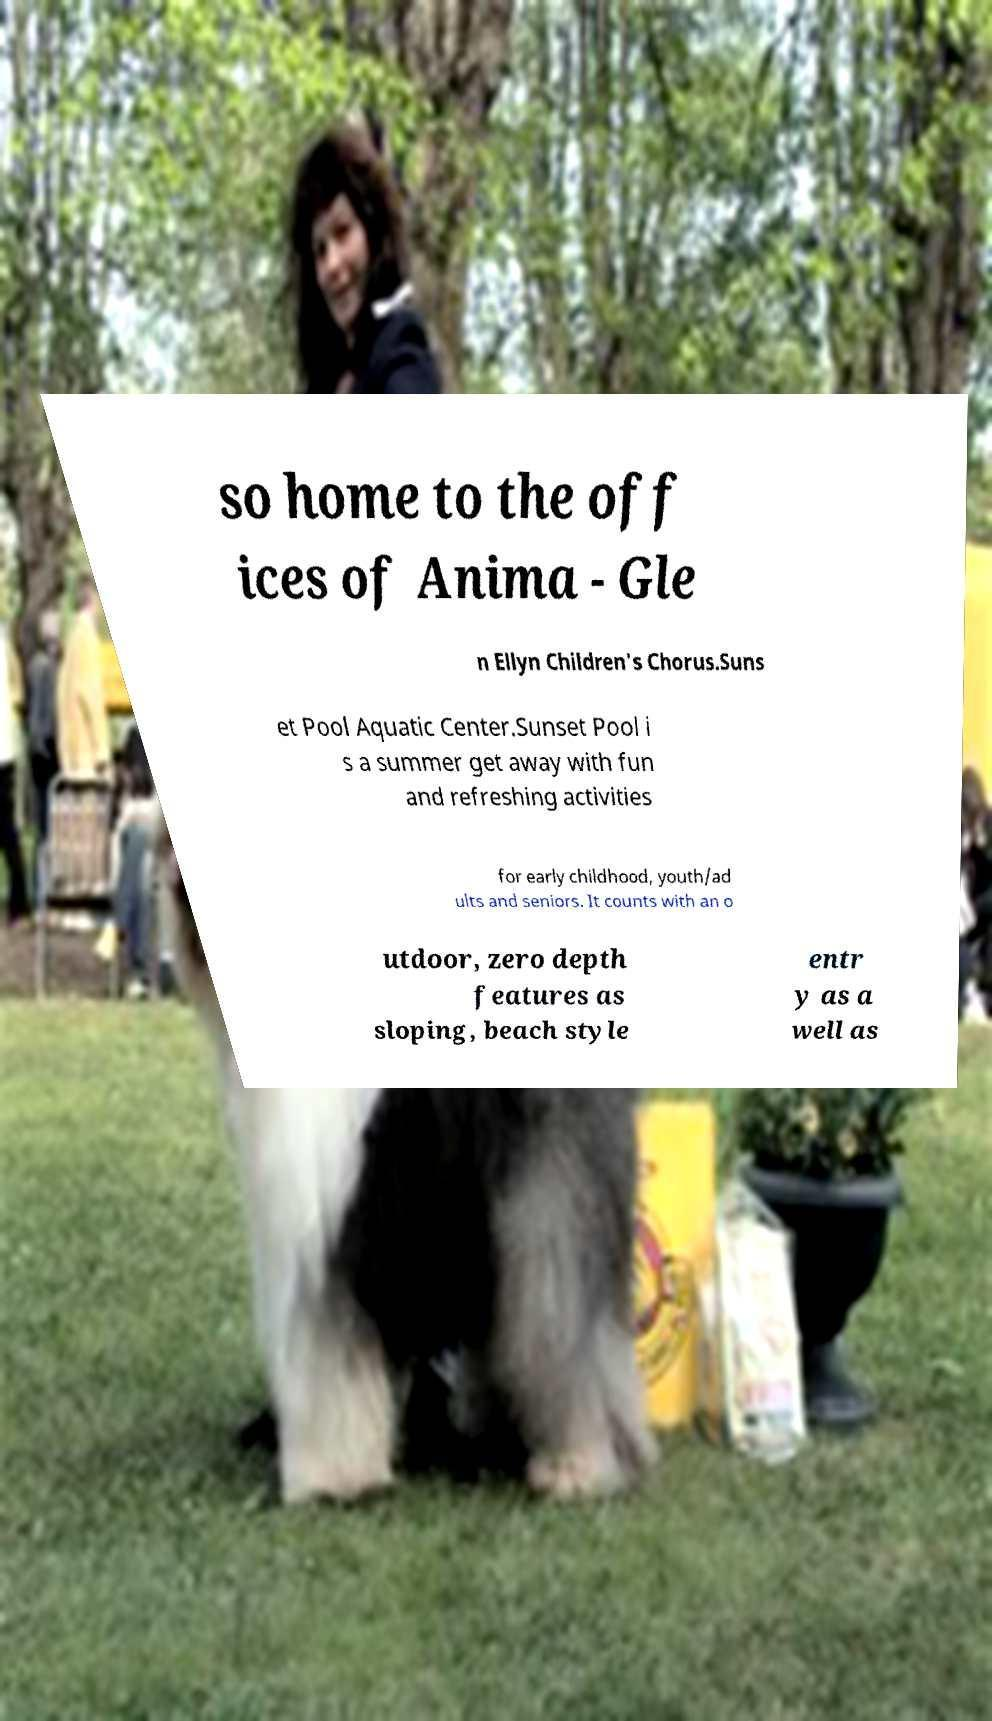I need the written content from this picture converted into text. Can you do that? so home to the off ices of Anima - Gle n Ellyn Children's Chorus.Suns et Pool Aquatic Center.Sunset Pool i s a summer get away with fun and refreshing activities for early childhood, youth/ad ults and seniors. It counts with an o utdoor, zero depth features as sloping, beach style entr y as a well as 